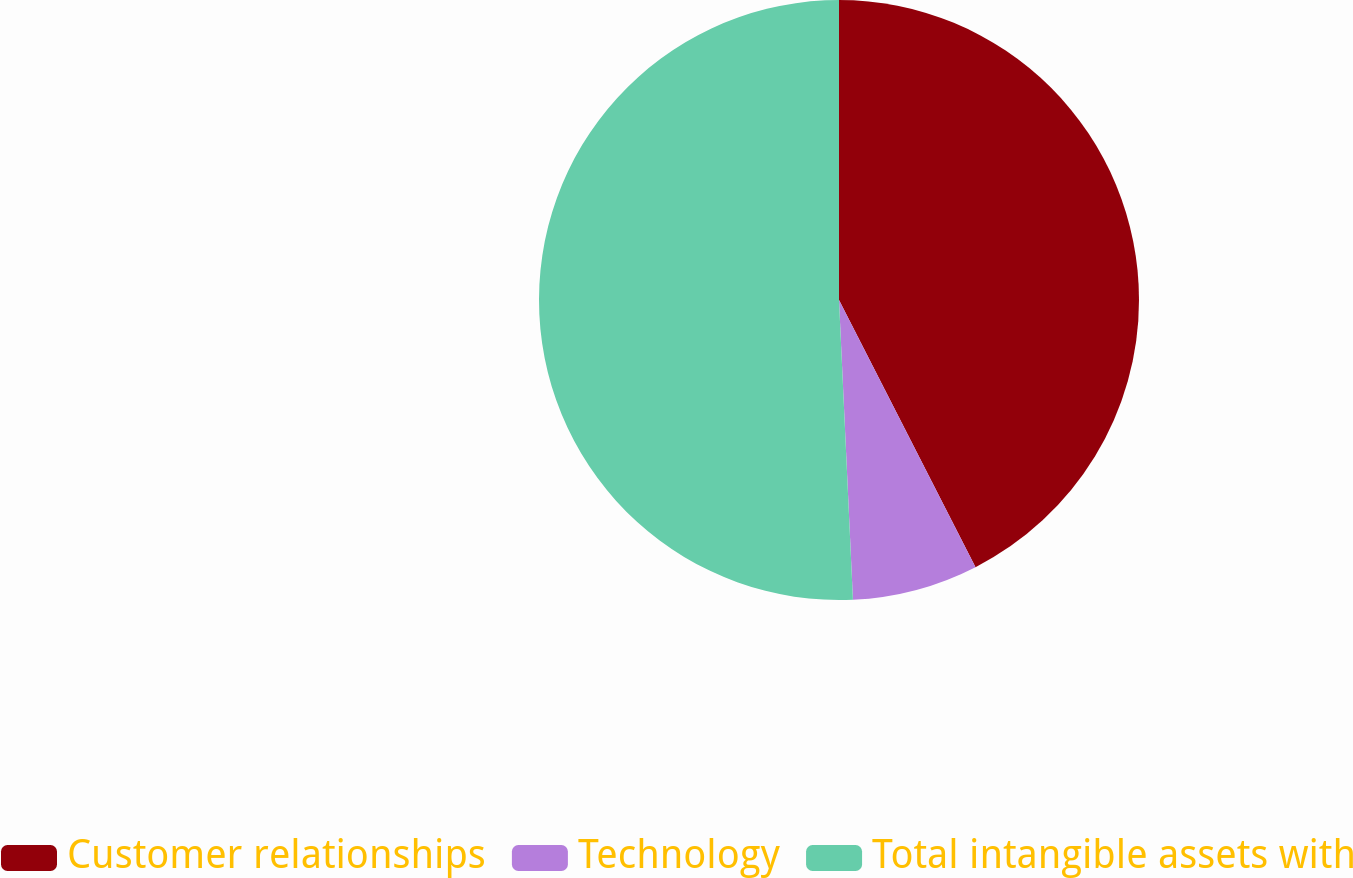Convert chart. <chart><loc_0><loc_0><loc_500><loc_500><pie_chart><fcel>Customer relationships<fcel>Technology<fcel>Total intangible assets with<nl><fcel>42.48%<fcel>6.78%<fcel>50.74%<nl></chart> 